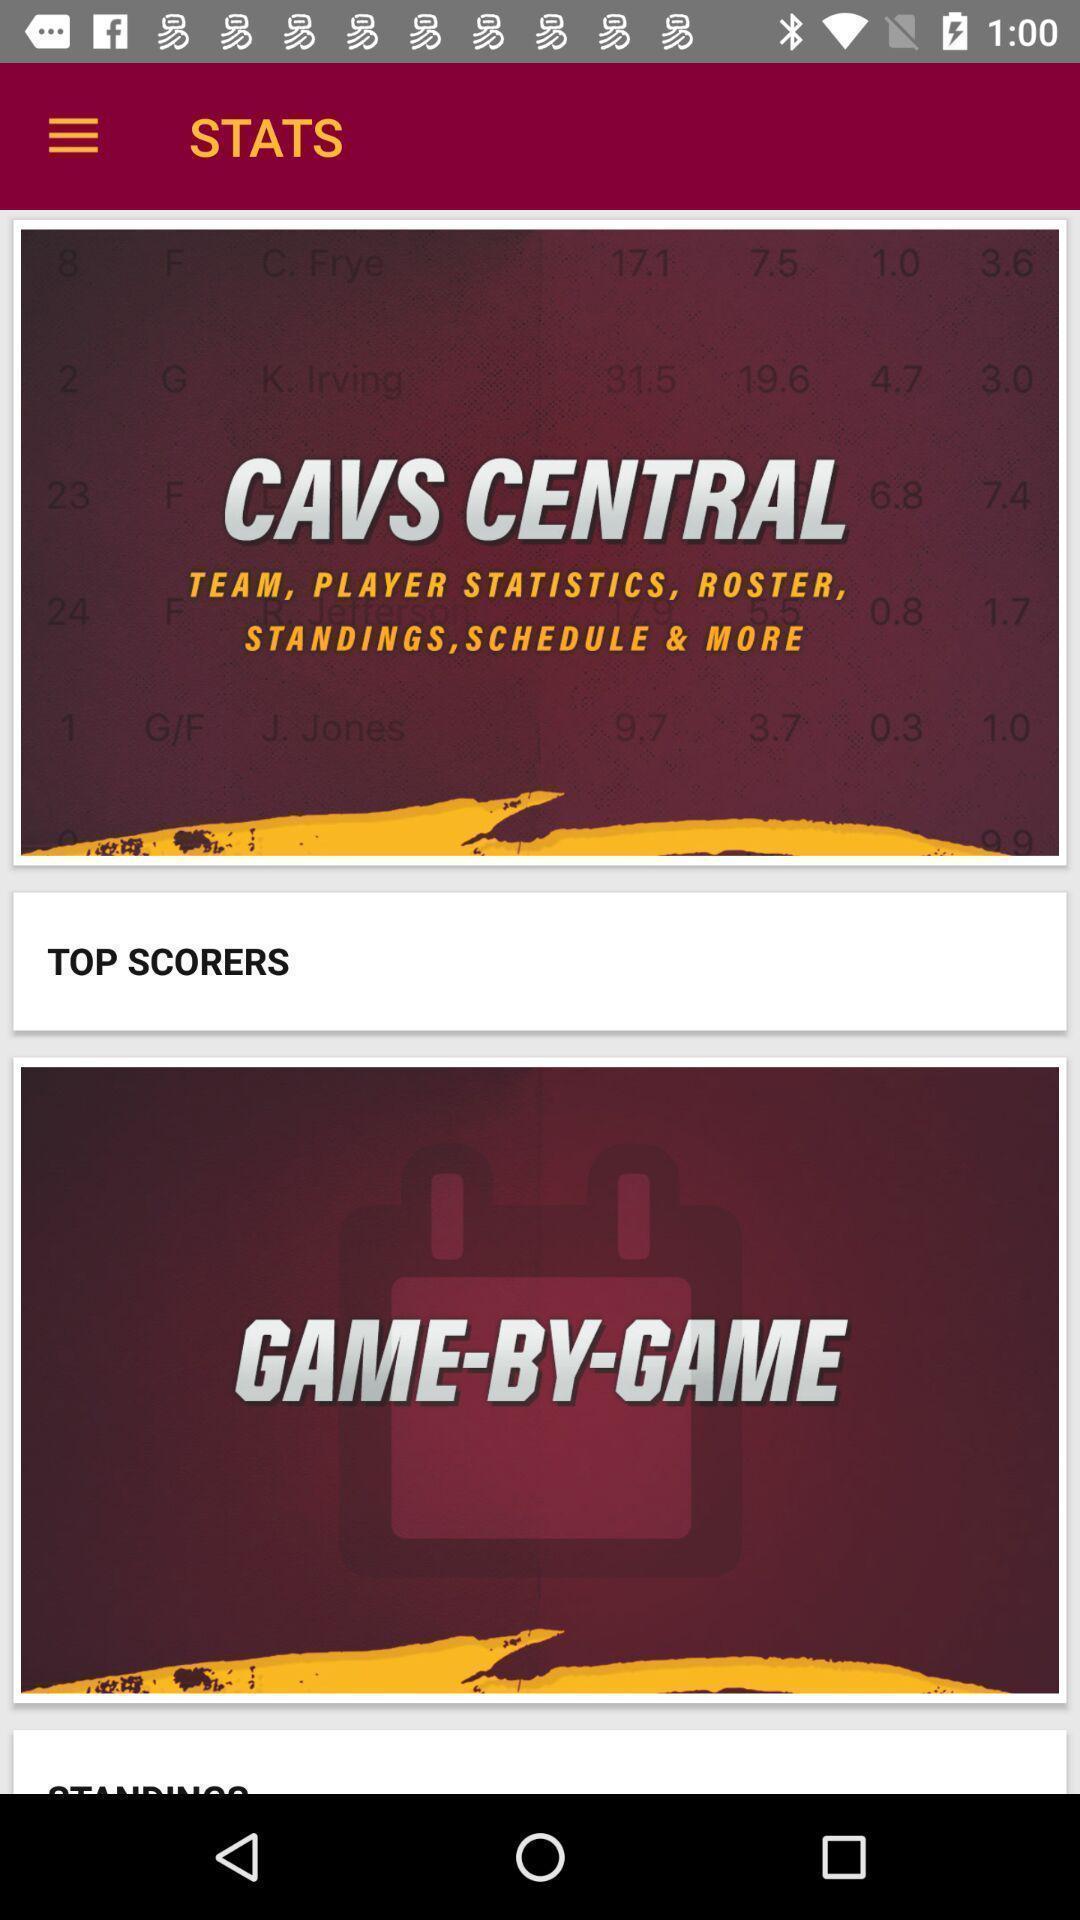Summarize the main components in this picture. Screen page displaying various information in gaming app. 